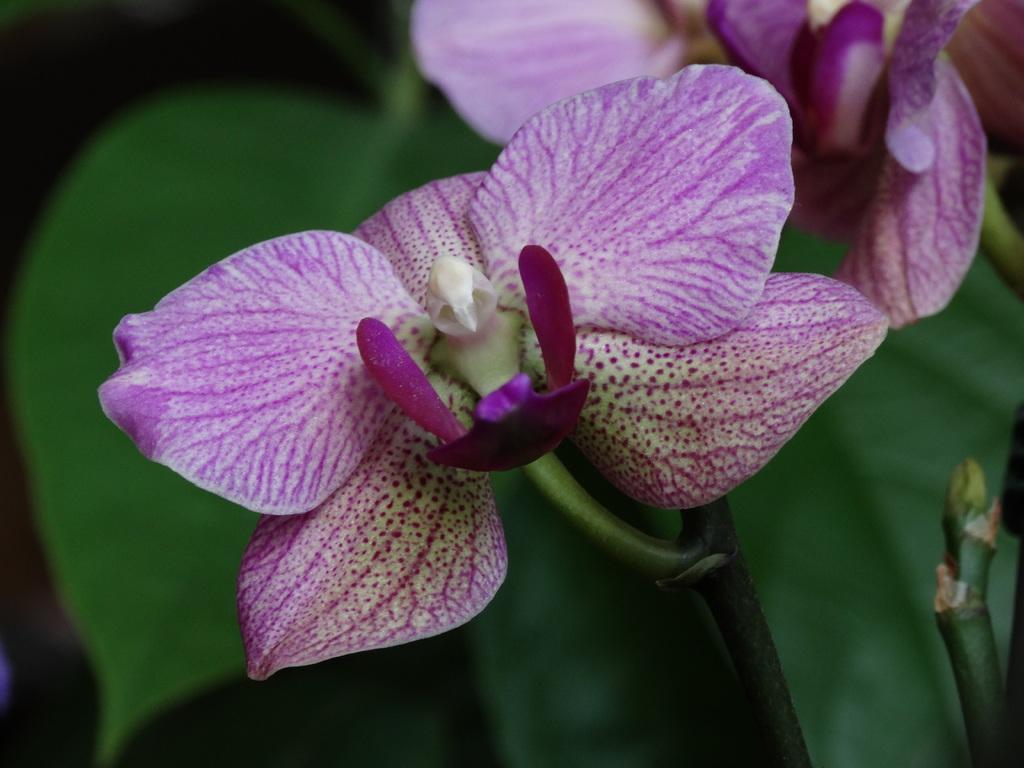How would you summarize this image in a sentence or two? In the image we can see flowers, pink and white in color. Here we can see the leaves and the background is dark. 